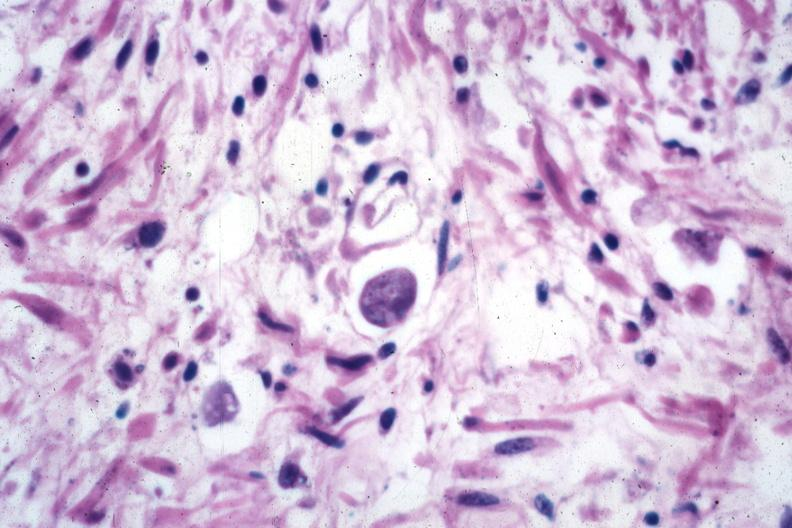does this image show trophozoite source?
Answer the question using a single word or phrase. Yes 